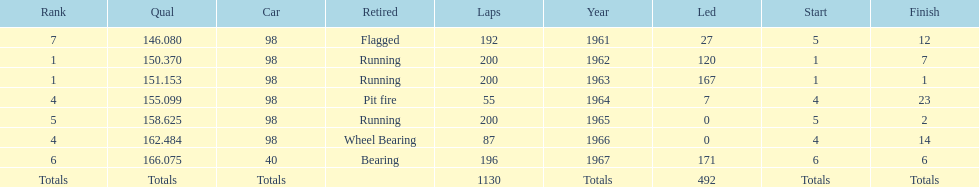What is the difference between the qualfying time in 1967 and 1965? 7.45. 